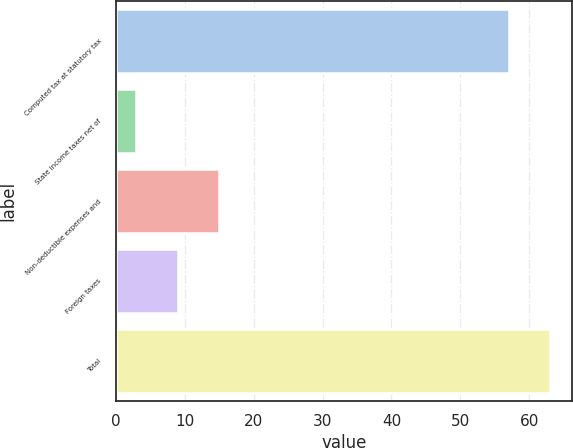<chart> <loc_0><loc_0><loc_500><loc_500><bar_chart><fcel>Computed tax at statutory tax<fcel>State income taxes net of<fcel>Non-deductible expenses and<fcel>Foreign taxes<fcel>Total<nl><fcel>57<fcel>3<fcel>15<fcel>9<fcel>63<nl></chart> 